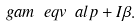<formula> <loc_0><loc_0><loc_500><loc_500>\ g a m \ e q v \ a l p + I \beta .</formula> 